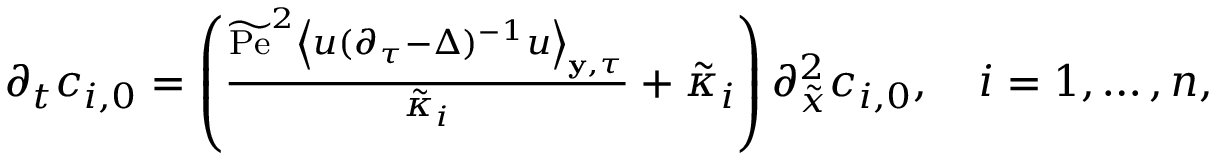Convert formula to latex. <formula><loc_0><loc_0><loc_500><loc_500>\begin{array} { r } { \partial _ { t } c _ { i , 0 } = \left ( \frac { \widetilde { P e } ^ { 2 } \left \langle u ( \partial _ { \tau } - \Delta ) ^ { - 1 } u \right \rangle _ { y , \tau } } { \tilde { \kappa } _ { i } } + \tilde { \kappa } _ { i } \right ) \partial _ { \tilde { x } } ^ { 2 } c _ { i , 0 } , \quad i = 1 , \hdots , n , } \end{array}</formula> 